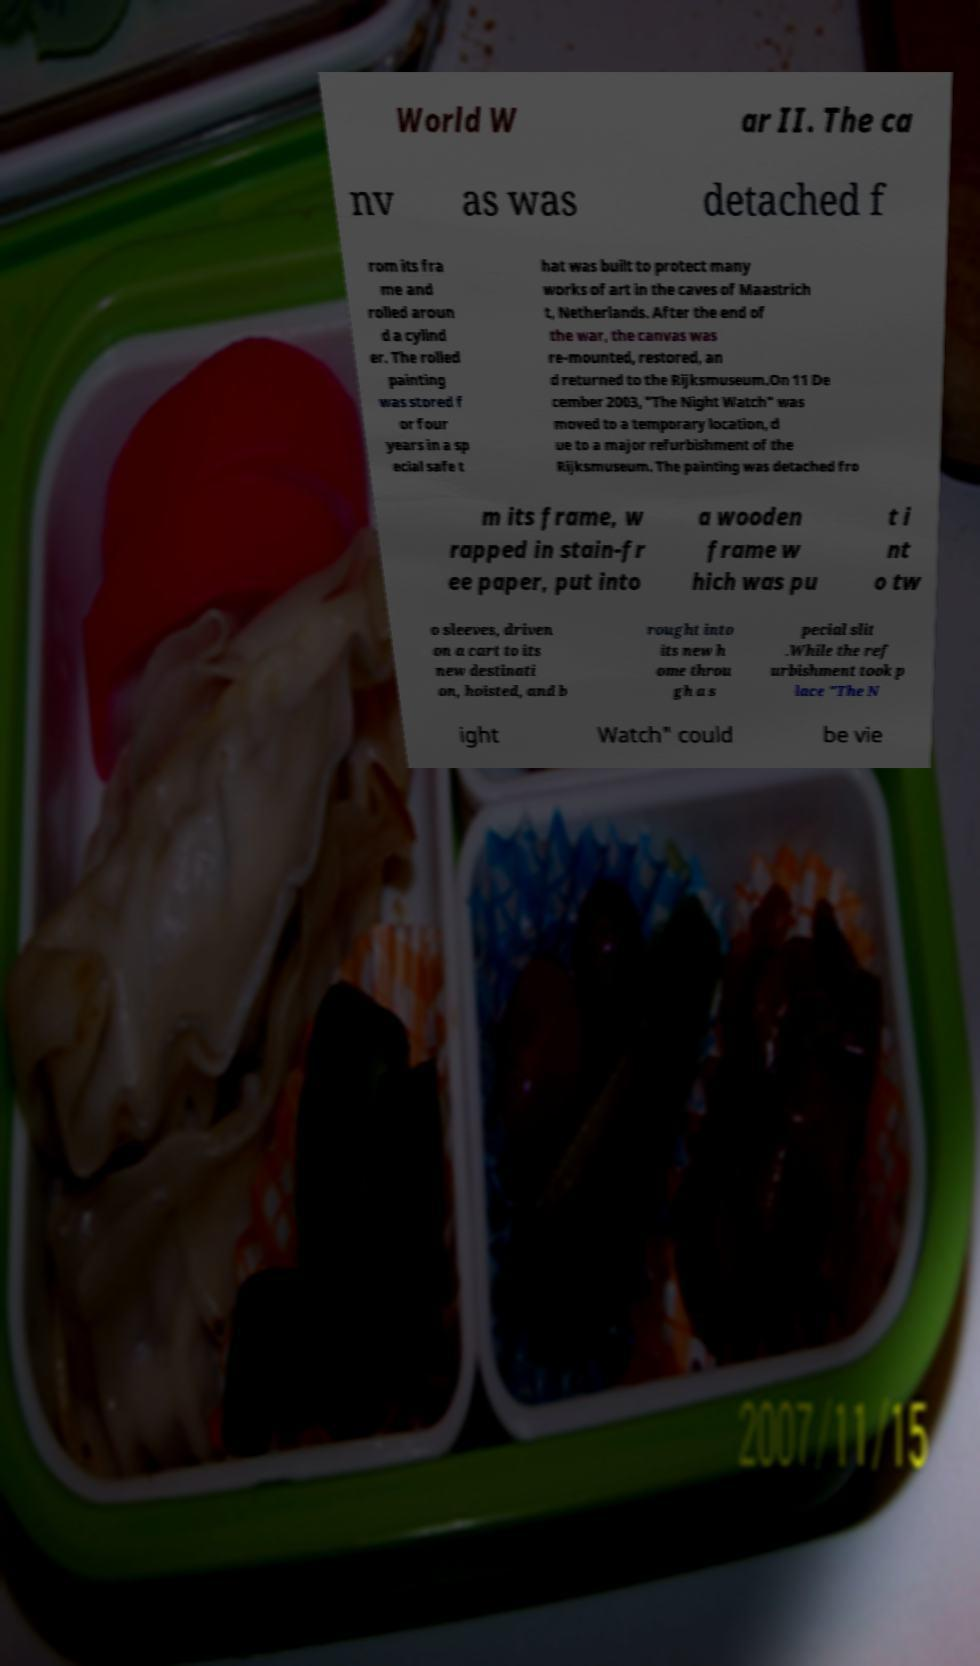Could you assist in decoding the text presented in this image and type it out clearly? World W ar II. The ca nv as was detached f rom its fra me and rolled aroun d a cylind er. The rolled painting was stored f or four years in a sp ecial safe t hat was built to protect many works of art in the caves of Maastrich t, Netherlands. After the end of the war, the canvas was re-mounted, restored, an d returned to the Rijksmuseum.On 11 De cember 2003, "The Night Watch" was moved to a temporary location, d ue to a major refurbishment of the Rijksmuseum. The painting was detached fro m its frame, w rapped in stain-fr ee paper, put into a wooden frame w hich was pu t i nt o tw o sleeves, driven on a cart to its new destinati on, hoisted, and b rought into its new h ome throu gh a s pecial slit .While the ref urbishment took p lace "The N ight Watch" could be vie 